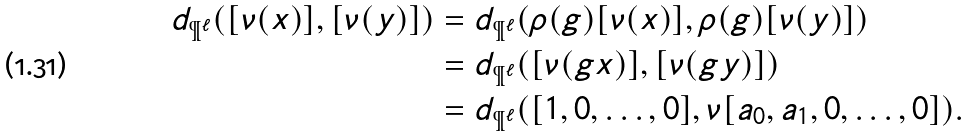<formula> <loc_0><loc_0><loc_500><loc_500>d _ { \P ^ { \ell } } ( [ \nu ( x ) ] , [ \nu ( y ) ] ) & = d _ { \P ^ { \ell } } ( \rho ( g ) [ \nu ( x ) ] , \rho ( g ) [ \nu ( y ) ] ) \\ & = d _ { \P ^ { \ell } } ( [ \nu ( g x ) ] , [ \nu ( g y ) ] ) \\ & = d _ { \P ^ { \ell } } ( [ 1 , 0 , \dots , 0 ] , \nu [ a _ { 0 } , a _ { 1 } , 0 , \dots , 0 ] ) .</formula> 